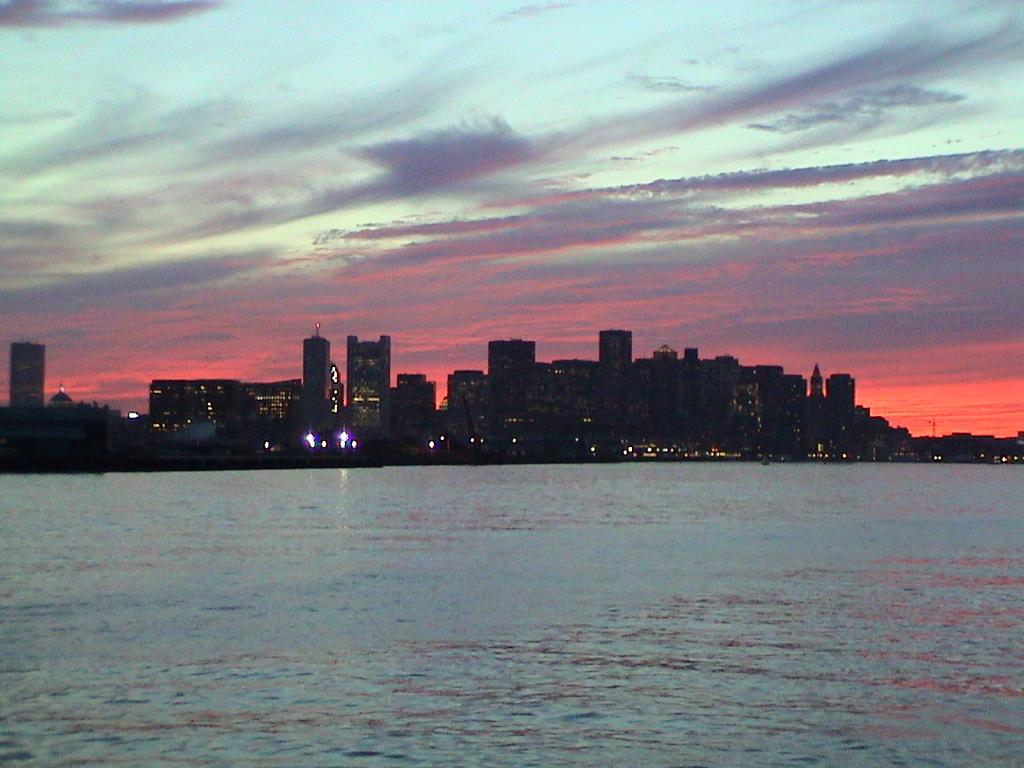What is the primary element visible in the image? There is water in the image. What type of structures can be seen in the image? There are buildings in the image. What can be seen illuminating the scene in the image? There are lights visible in the image. What is visible at the top of the image? The sky is visible at the top of the image. What type of juice is being served in the image? There is no juice present in the image; it features water, buildings, lights, and the sky. What time is displayed on the clock in the image? There is no clock present in the image. 